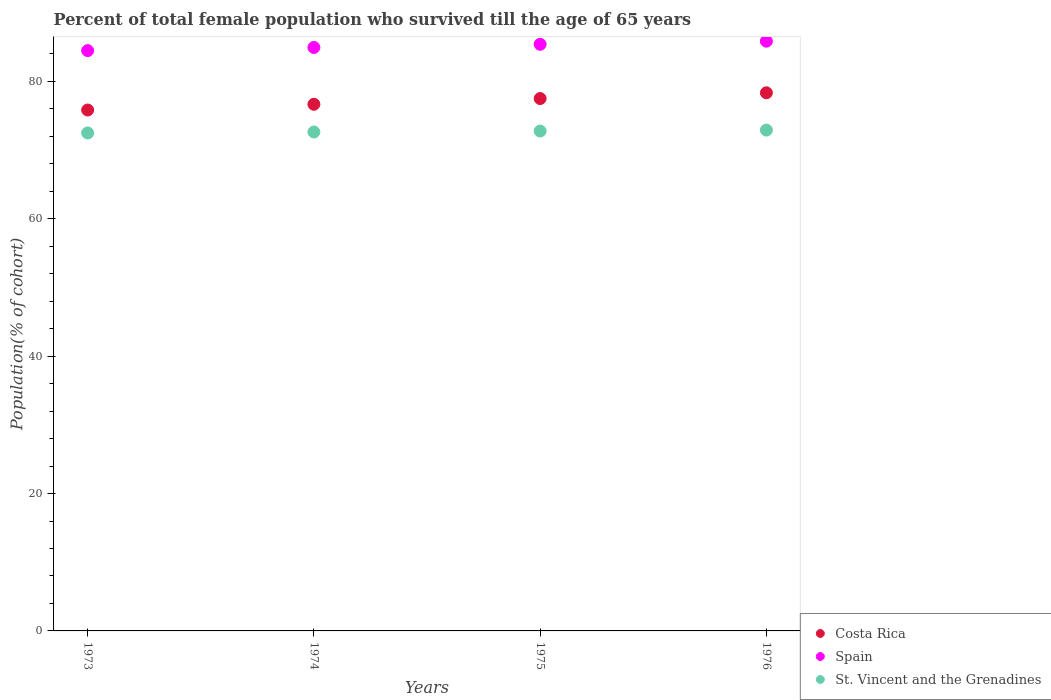What is the percentage of total female population who survived till the age of 65 years in Costa Rica in 1974?
Your answer should be very brief. 76.68. Across all years, what is the maximum percentage of total female population who survived till the age of 65 years in Costa Rica?
Offer a very short reply. 78.35. Across all years, what is the minimum percentage of total female population who survived till the age of 65 years in Costa Rica?
Your response must be concise. 75.84. In which year was the percentage of total female population who survived till the age of 65 years in St. Vincent and the Grenadines maximum?
Your response must be concise. 1976. What is the total percentage of total female population who survived till the age of 65 years in St. Vincent and the Grenadines in the graph?
Your answer should be very brief. 290.84. What is the difference between the percentage of total female population who survived till the age of 65 years in Costa Rica in 1973 and that in 1976?
Offer a terse response. -2.51. What is the difference between the percentage of total female population who survived till the age of 65 years in Spain in 1973 and the percentage of total female population who survived till the age of 65 years in St. Vincent and the Grenadines in 1974?
Offer a terse response. 11.85. What is the average percentage of total female population who survived till the age of 65 years in Costa Rica per year?
Provide a succinct answer. 77.09. In the year 1974, what is the difference between the percentage of total female population who survived till the age of 65 years in St. Vincent and the Grenadines and percentage of total female population who survived till the age of 65 years in Spain?
Provide a succinct answer. -12.31. What is the ratio of the percentage of total female population who survived till the age of 65 years in Costa Rica in 1973 to that in 1974?
Your answer should be compact. 0.99. Is the percentage of total female population who survived till the age of 65 years in Spain in 1973 less than that in 1975?
Make the answer very short. Yes. Is the difference between the percentage of total female population who survived till the age of 65 years in St. Vincent and the Grenadines in 1973 and 1975 greater than the difference between the percentage of total female population who survived till the age of 65 years in Spain in 1973 and 1975?
Offer a very short reply. Yes. What is the difference between the highest and the second highest percentage of total female population who survived till the age of 65 years in St. Vincent and the Grenadines?
Offer a terse response. 0.14. What is the difference between the highest and the lowest percentage of total female population who survived till the age of 65 years in St. Vincent and the Grenadines?
Make the answer very short. 0.42. In how many years, is the percentage of total female population who survived till the age of 65 years in Costa Rica greater than the average percentage of total female population who survived till the age of 65 years in Costa Rica taken over all years?
Make the answer very short. 2. How many dotlines are there?
Your answer should be very brief. 3. How many years are there in the graph?
Ensure brevity in your answer.  4. Are the values on the major ticks of Y-axis written in scientific E-notation?
Make the answer very short. No. Does the graph contain any zero values?
Ensure brevity in your answer.  No. Does the graph contain grids?
Make the answer very short. No. How many legend labels are there?
Your answer should be very brief. 3. What is the title of the graph?
Ensure brevity in your answer.  Percent of total female population who survived till the age of 65 years. What is the label or title of the Y-axis?
Offer a terse response. Population(% of cohort). What is the Population(% of cohort) of Costa Rica in 1973?
Offer a terse response. 75.84. What is the Population(% of cohort) of Spain in 1973?
Offer a terse response. 84.49. What is the Population(% of cohort) in St. Vincent and the Grenadines in 1973?
Ensure brevity in your answer.  72.5. What is the Population(% of cohort) of Costa Rica in 1974?
Provide a short and direct response. 76.68. What is the Population(% of cohort) of Spain in 1974?
Ensure brevity in your answer.  84.95. What is the Population(% of cohort) of St. Vincent and the Grenadines in 1974?
Keep it short and to the point. 72.64. What is the Population(% of cohort) of Costa Rica in 1975?
Your answer should be very brief. 77.51. What is the Population(% of cohort) of Spain in 1975?
Make the answer very short. 85.41. What is the Population(% of cohort) in St. Vincent and the Grenadines in 1975?
Provide a succinct answer. 72.78. What is the Population(% of cohort) in Costa Rica in 1976?
Offer a very short reply. 78.35. What is the Population(% of cohort) in Spain in 1976?
Your answer should be compact. 85.87. What is the Population(% of cohort) in St. Vincent and the Grenadines in 1976?
Give a very brief answer. 72.92. Across all years, what is the maximum Population(% of cohort) in Costa Rica?
Your answer should be compact. 78.35. Across all years, what is the maximum Population(% of cohort) of Spain?
Provide a succinct answer. 85.87. Across all years, what is the maximum Population(% of cohort) in St. Vincent and the Grenadines?
Offer a very short reply. 72.92. Across all years, what is the minimum Population(% of cohort) in Costa Rica?
Give a very brief answer. 75.84. Across all years, what is the minimum Population(% of cohort) of Spain?
Provide a succinct answer. 84.49. Across all years, what is the minimum Population(% of cohort) in St. Vincent and the Grenadines?
Give a very brief answer. 72.5. What is the total Population(% of cohort) in Costa Rica in the graph?
Give a very brief answer. 308.38. What is the total Population(% of cohort) in Spain in the graph?
Offer a terse response. 340.72. What is the total Population(% of cohort) of St. Vincent and the Grenadines in the graph?
Provide a succinct answer. 290.84. What is the difference between the Population(% of cohort) in Costa Rica in 1973 and that in 1974?
Provide a succinct answer. -0.84. What is the difference between the Population(% of cohort) of Spain in 1973 and that in 1974?
Provide a short and direct response. -0.46. What is the difference between the Population(% of cohort) of St. Vincent and the Grenadines in 1973 and that in 1974?
Your answer should be very brief. -0.14. What is the difference between the Population(% of cohort) of Costa Rica in 1973 and that in 1975?
Your response must be concise. -1.67. What is the difference between the Population(% of cohort) of Spain in 1973 and that in 1975?
Offer a terse response. -0.92. What is the difference between the Population(% of cohort) in St. Vincent and the Grenadines in 1973 and that in 1975?
Provide a short and direct response. -0.28. What is the difference between the Population(% of cohort) in Costa Rica in 1973 and that in 1976?
Make the answer very short. -2.51. What is the difference between the Population(% of cohort) in Spain in 1973 and that in 1976?
Give a very brief answer. -1.37. What is the difference between the Population(% of cohort) in St. Vincent and the Grenadines in 1973 and that in 1976?
Ensure brevity in your answer.  -0.42. What is the difference between the Population(% of cohort) in Costa Rica in 1974 and that in 1975?
Make the answer very short. -0.84. What is the difference between the Population(% of cohort) of Spain in 1974 and that in 1975?
Your answer should be compact. -0.46. What is the difference between the Population(% of cohort) of St. Vincent and the Grenadines in 1974 and that in 1975?
Your response must be concise. -0.14. What is the difference between the Population(% of cohort) in Costa Rica in 1974 and that in 1976?
Offer a terse response. -1.67. What is the difference between the Population(% of cohort) of Spain in 1974 and that in 1976?
Provide a succinct answer. -0.92. What is the difference between the Population(% of cohort) in St. Vincent and the Grenadines in 1974 and that in 1976?
Give a very brief answer. -0.28. What is the difference between the Population(% of cohort) of Costa Rica in 1975 and that in 1976?
Ensure brevity in your answer.  -0.84. What is the difference between the Population(% of cohort) in Spain in 1975 and that in 1976?
Offer a very short reply. -0.46. What is the difference between the Population(% of cohort) of St. Vincent and the Grenadines in 1975 and that in 1976?
Your answer should be compact. -0.14. What is the difference between the Population(% of cohort) of Costa Rica in 1973 and the Population(% of cohort) of Spain in 1974?
Offer a terse response. -9.11. What is the difference between the Population(% of cohort) of Costa Rica in 1973 and the Population(% of cohort) of St. Vincent and the Grenadines in 1974?
Offer a very short reply. 3.2. What is the difference between the Population(% of cohort) of Spain in 1973 and the Population(% of cohort) of St. Vincent and the Grenadines in 1974?
Provide a succinct answer. 11.85. What is the difference between the Population(% of cohort) of Costa Rica in 1973 and the Population(% of cohort) of Spain in 1975?
Offer a terse response. -9.57. What is the difference between the Population(% of cohort) in Costa Rica in 1973 and the Population(% of cohort) in St. Vincent and the Grenadines in 1975?
Make the answer very short. 3.06. What is the difference between the Population(% of cohort) in Spain in 1973 and the Population(% of cohort) in St. Vincent and the Grenadines in 1975?
Your answer should be very brief. 11.71. What is the difference between the Population(% of cohort) in Costa Rica in 1973 and the Population(% of cohort) in Spain in 1976?
Ensure brevity in your answer.  -10.03. What is the difference between the Population(% of cohort) of Costa Rica in 1973 and the Population(% of cohort) of St. Vincent and the Grenadines in 1976?
Your response must be concise. 2.92. What is the difference between the Population(% of cohort) of Spain in 1973 and the Population(% of cohort) of St. Vincent and the Grenadines in 1976?
Give a very brief answer. 11.57. What is the difference between the Population(% of cohort) of Costa Rica in 1974 and the Population(% of cohort) of Spain in 1975?
Offer a terse response. -8.73. What is the difference between the Population(% of cohort) of Costa Rica in 1974 and the Population(% of cohort) of St. Vincent and the Grenadines in 1975?
Your answer should be compact. 3.9. What is the difference between the Population(% of cohort) of Spain in 1974 and the Population(% of cohort) of St. Vincent and the Grenadines in 1975?
Provide a succinct answer. 12.17. What is the difference between the Population(% of cohort) in Costa Rica in 1974 and the Population(% of cohort) in Spain in 1976?
Your response must be concise. -9.19. What is the difference between the Population(% of cohort) of Costa Rica in 1974 and the Population(% of cohort) of St. Vincent and the Grenadines in 1976?
Your answer should be very brief. 3.76. What is the difference between the Population(% of cohort) of Spain in 1974 and the Population(% of cohort) of St. Vincent and the Grenadines in 1976?
Your response must be concise. 12.03. What is the difference between the Population(% of cohort) in Costa Rica in 1975 and the Population(% of cohort) in Spain in 1976?
Provide a succinct answer. -8.35. What is the difference between the Population(% of cohort) of Costa Rica in 1975 and the Population(% of cohort) of St. Vincent and the Grenadines in 1976?
Make the answer very short. 4.59. What is the difference between the Population(% of cohort) in Spain in 1975 and the Population(% of cohort) in St. Vincent and the Grenadines in 1976?
Offer a terse response. 12.49. What is the average Population(% of cohort) in Costa Rica per year?
Your response must be concise. 77.09. What is the average Population(% of cohort) of Spain per year?
Give a very brief answer. 85.18. What is the average Population(% of cohort) of St. Vincent and the Grenadines per year?
Offer a terse response. 72.71. In the year 1973, what is the difference between the Population(% of cohort) in Costa Rica and Population(% of cohort) in Spain?
Keep it short and to the point. -8.65. In the year 1973, what is the difference between the Population(% of cohort) of Costa Rica and Population(% of cohort) of St. Vincent and the Grenadines?
Keep it short and to the point. 3.34. In the year 1973, what is the difference between the Population(% of cohort) in Spain and Population(% of cohort) in St. Vincent and the Grenadines?
Provide a succinct answer. 11.99. In the year 1974, what is the difference between the Population(% of cohort) of Costa Rica and Population(% of cohort) of Spain?
Make the answer very short. -8.27. In the year 1974, what is the difference between the Population(% of cohort) in Costa Rica and Population(% of cohort) in St. Vincent and the Grenadines?
Ensure brevity in your answer.  4.04. In the year 1974, what is the difference between the Population(% of cohort) of Spain and Population(% of cohort) of St. Vincent and the Grenadines?
Your answer should be compact. 12.31. In the year 1975, what is the difference between the Population(% of cohort) in Costa Rica and Population(% of cohort) in Spain?
Offer a very short reply. -7.9. In the year 1975, what is the difference between the Population(% of cohort) in Costa Rica and Population(% of cohort) in St. Vincent and the Grenadines?
Provide a succinct answer. 4.73. In the year 1975, what is the difference between the Population(% of cohort) of Spain and Population(% of cohort) of St. Vincent and the Grenadines?
Provide a succinct answer. 12.63. In the year 1976, what is the difference between the Population(% of cohort) in Costa Rica and Population(% of cohort) in Spain?
Make the answer very short. -7.52. In the year 1976, what is the difference between the Population(% of cohort) of Costa Rica and Population(% of cohort) of St. Vincent and the Grenadines?
Keep it short and to the point. 5.43. In the year 1976, what is the difference between the Population(% of cohort) in Spain and Population(% of cohort) in St. Vincent and the Grenadines?
Keep it short and to the point. 12.95. What is the ratio of the Population(% of cohort) in Costa Rica in 1973 to that in 1975?
Your response must be concise. 0.98. What is the ratio of the Population(% of cohort) of Spain in 1973 to that in 1975?
Give a very brief answer. 0.99. What is the ratio of the Population(% of cohort) in St. Vincent and the Grenadines in 1973 to that in 1975?
Your response must be concise. 1. What is the ratio of the Population(% of cohort) in Spain in 1973 to that in 1976?
Your answer should be very brief. 0.98. What is the ratio of the Population(% of cohort) of Costa Rica in 1974 to that in 1975?
Provide a short and direct response. 0.99. What is the ratio of the Population(% of cohort) of Spain in 1974 to that in 1975?
Provide a succinct answer. 0.99. What is the ratio of the Population(% of cohort) of Costa Rica in 1974 to that in 1976?
Ensure brevity in your answer.  0.98. What is the ratio of the Population(% of cohort) of Spain in 1974 to that in 1976?
Keep it short and to the point. 0.99. What is the ratio of the Population(% of cohort) of Costa Rica in 1975 to that in 1976?
Ensure brevity in your answer.  0.99. What is the ratio of the Population(% of cohort) in St. Vincent and the Grenadines in 1975 to that in 1976?
Make the answer very short. 1. What is the difference between the highest and the second highest Population(% of cohort) of Costa Rica?
Your response must be concise. 0.84. What is the difference between the highest and the second highest Population(% of cohort) in Spain?
Your answer should be very brief. 0.46. What is the difference between the highest and the second highest Population(% of cohort) in St. Vincent and the Grenadines?
Offer a very short reply. 0.14. What is the difference between the highest and the lowest Population(% of cohort) of Costa Rica?
Your answer should be compact. 2.51. What is the difference between the highest and the lowest Population(% of cohort) of Spain?
Offer a very short reply. 1.37. What is the difference between the highest and the lowest Population(% of cohort) of St. Vincent and the Grenadines?
Give a very brief answer. 0.42. 